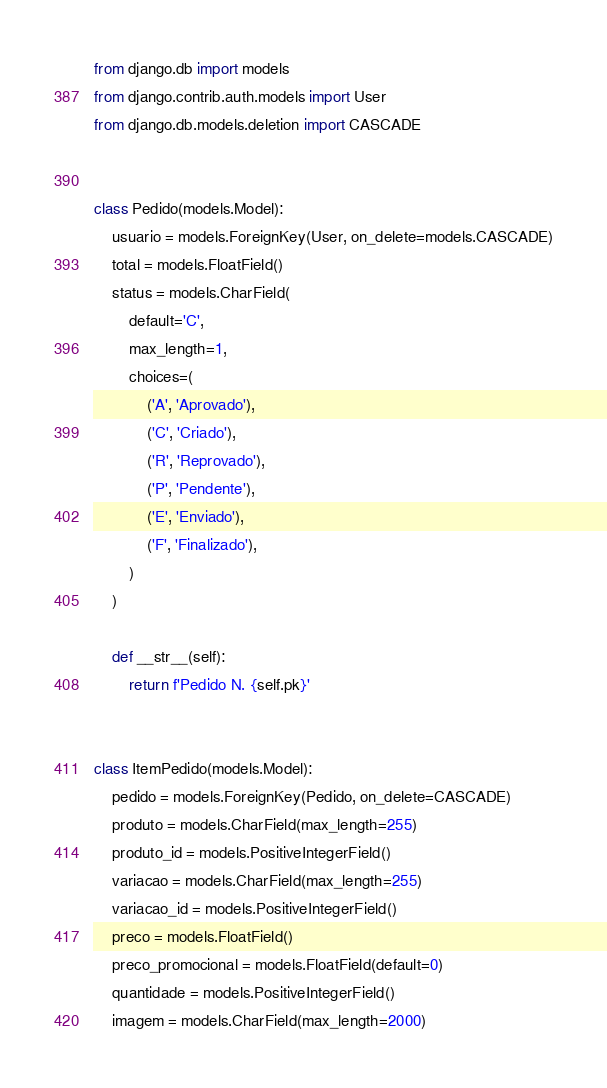<code> <loc_0><loc_0><loc_500><loc_500><_Python_>from django.db import models
from django.contrib.auth.models import User
from django.db.models.deletion import CASCADE


class Pedido(models.Model):
    usuario = models.ForeignKey(User, on_delete=models.CASCADE)
    total = models.FloatField()
    status = models.CharField(
        default='C',
        max_length=1,
        choices=(
            ('A', 'Aprovado'),
            ('C', 'Criado'),
            ('R', 'Reprovado'),
            ('P', 'Pendente'),
            ('E', 'Enviado'),
            ('F', 'Finalizado'),
        )
    )

    def __str__(self):
        return f'Pedido N. {self.pk}'


class ItemPedido(models.Model):
    pedido = models.ForeignKey(Pedido, on_delete=CASCADE)
    produto = models.CharField(max_length=255)
    produto_id = models.PositiveIntegerField()
    variacao = models.CharField(max_length=255)
    variacao_id = models.PositiveIntegerField()
    preco = models.FloatField()
    preco_promocional = models.FloatField(default=0)
    quantidade = models.PositiveIntegerField()
    imagem = models.CharField(max_length=2000)
</code> 